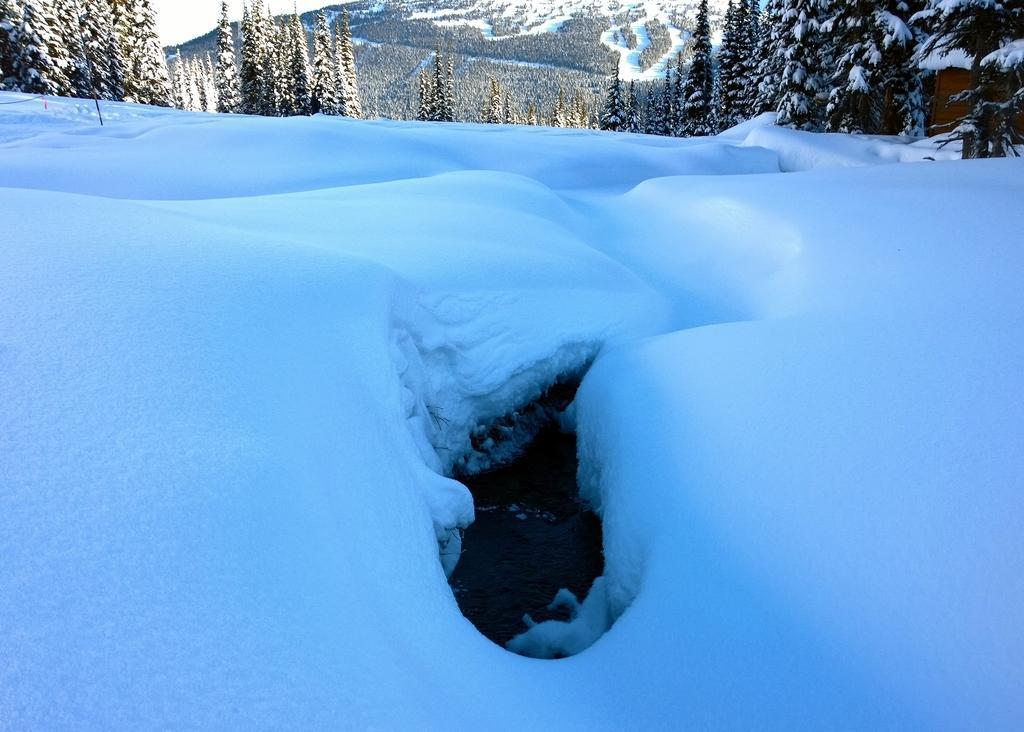Please provide a concise description of this image. In this picture I can see the snow. In the background I can see the trees and mountain. In the top left corner I can see the sky. In the top right corner there is a hut. 